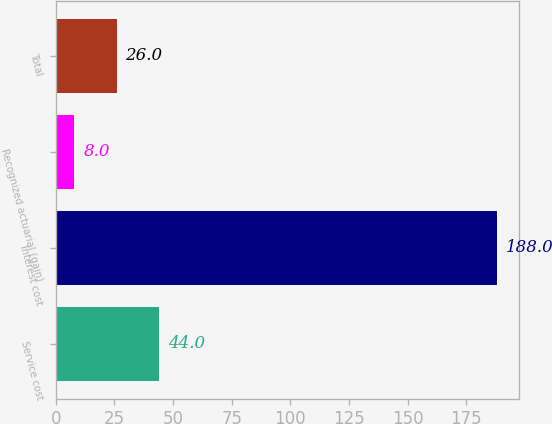<chart> <loc_0><loc_0><loc_500><loc_500><bar_chart><fcel>Service cost<fcel>Interest cost<fcel>Recognized actuarial (gain)<fcel>Total<nl><fcel>44<fcel>188<fcel>8<fcel>26<nl></chart> 